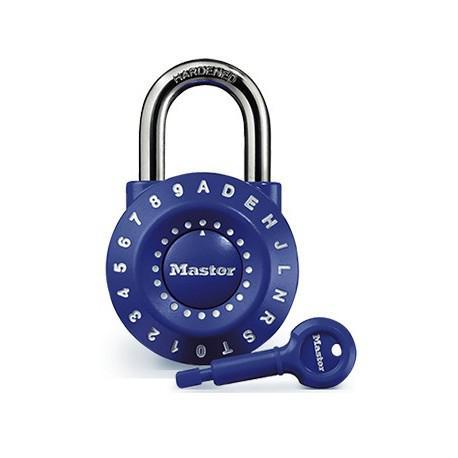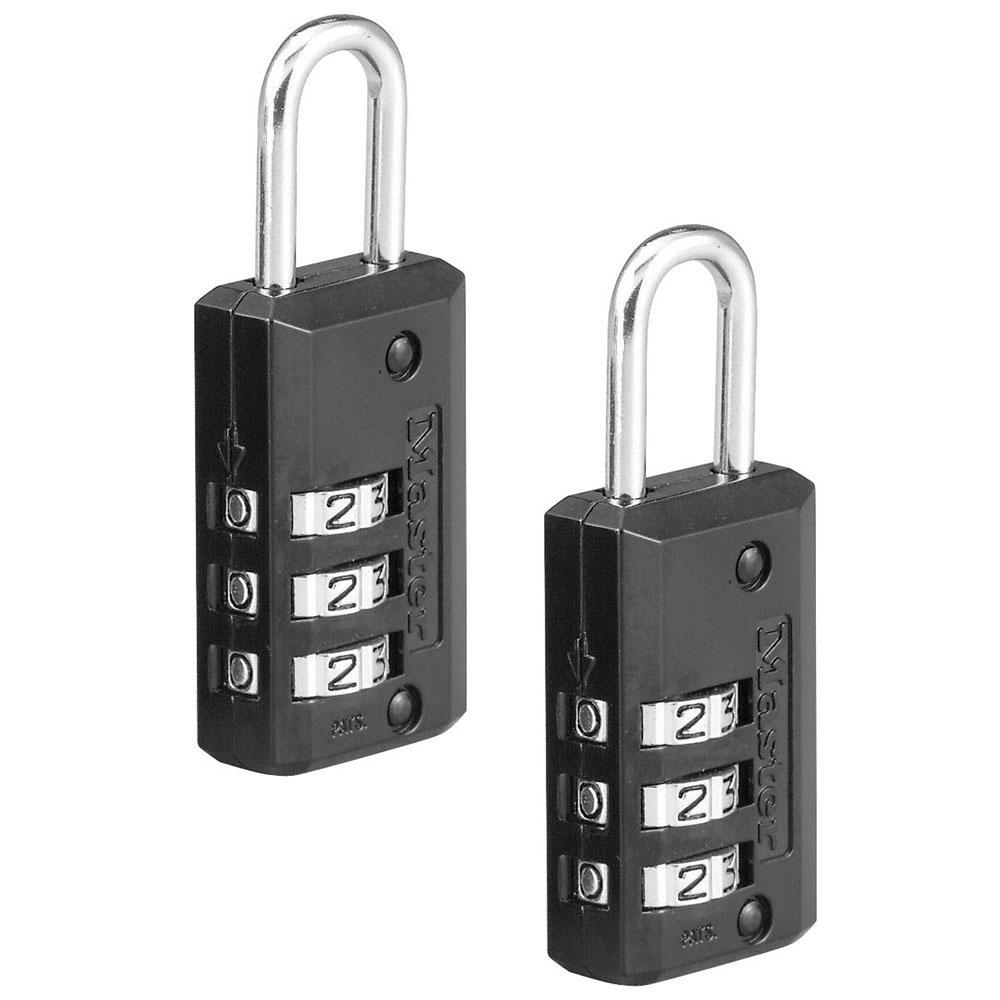The first image is the image on the left, the second image is the image on the right. Given the left and right images, does the statement "An image shows a round lock with a key next to it, but not inserted in it." hold true? Answer yes or no. Yes. The first image is the image on the left, the second image is the image on the right. Assess this claim about the two images: "A lock in one image is round with a front dial and optional key, while a second image shows at least one padlock with number belts that scroll.". Correct or not? Answer yes or no. Yes. 